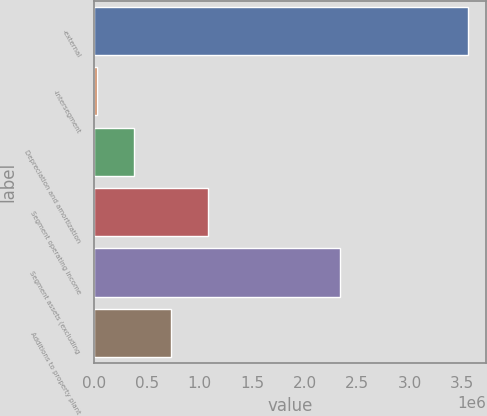Convert chart. <chart><loc_0><loc_0><loc_500><loc_500><bar_chart><fcel>-external<fcel>-intersegment<fcel>Depreciation and amortization<fcel>Segment operating income<fcel>Segment assets (excluding<fcel>Additions to property plant<nl><fcel>3.5541e+06<fcel>22724<fcel>375862<fcel>1.08214e+06<fcel>2.3376e+06<fcel>728999<nl></chart> 